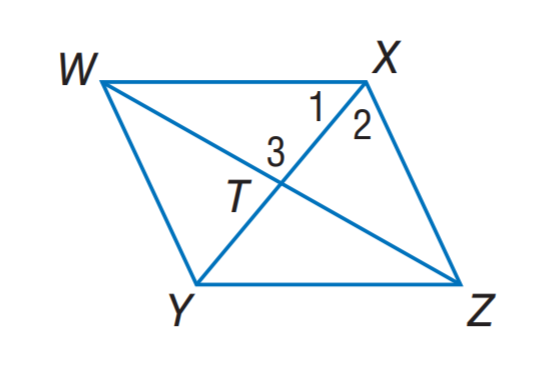Answer the mathemtical geometry problem and directly provide the correct option letter.
Question: Quadrilateral W X Z Y is a rhombus. If m \angle X Z Y = 56, find m \angle Y W Z.
Choices: A: 14 B: 28 C: 34 D: 56 B 